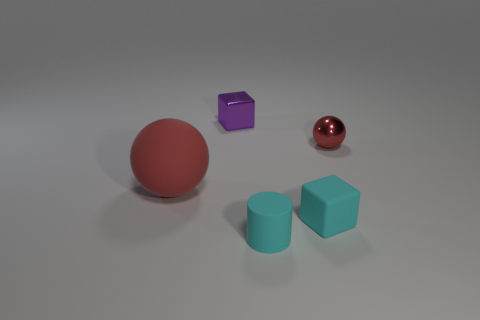Considering their shapes and spacing, what sort of composition principles can be observed in this arrangement? The objects are arranged according to principles of balance and contrast. The spherical shapes create a sense of flow, while the cube shapes provide stability. The spacing between the objects gives the composition a sense of harmony and avoids clutter, while the variety in color introduces contrast and visual interest. 